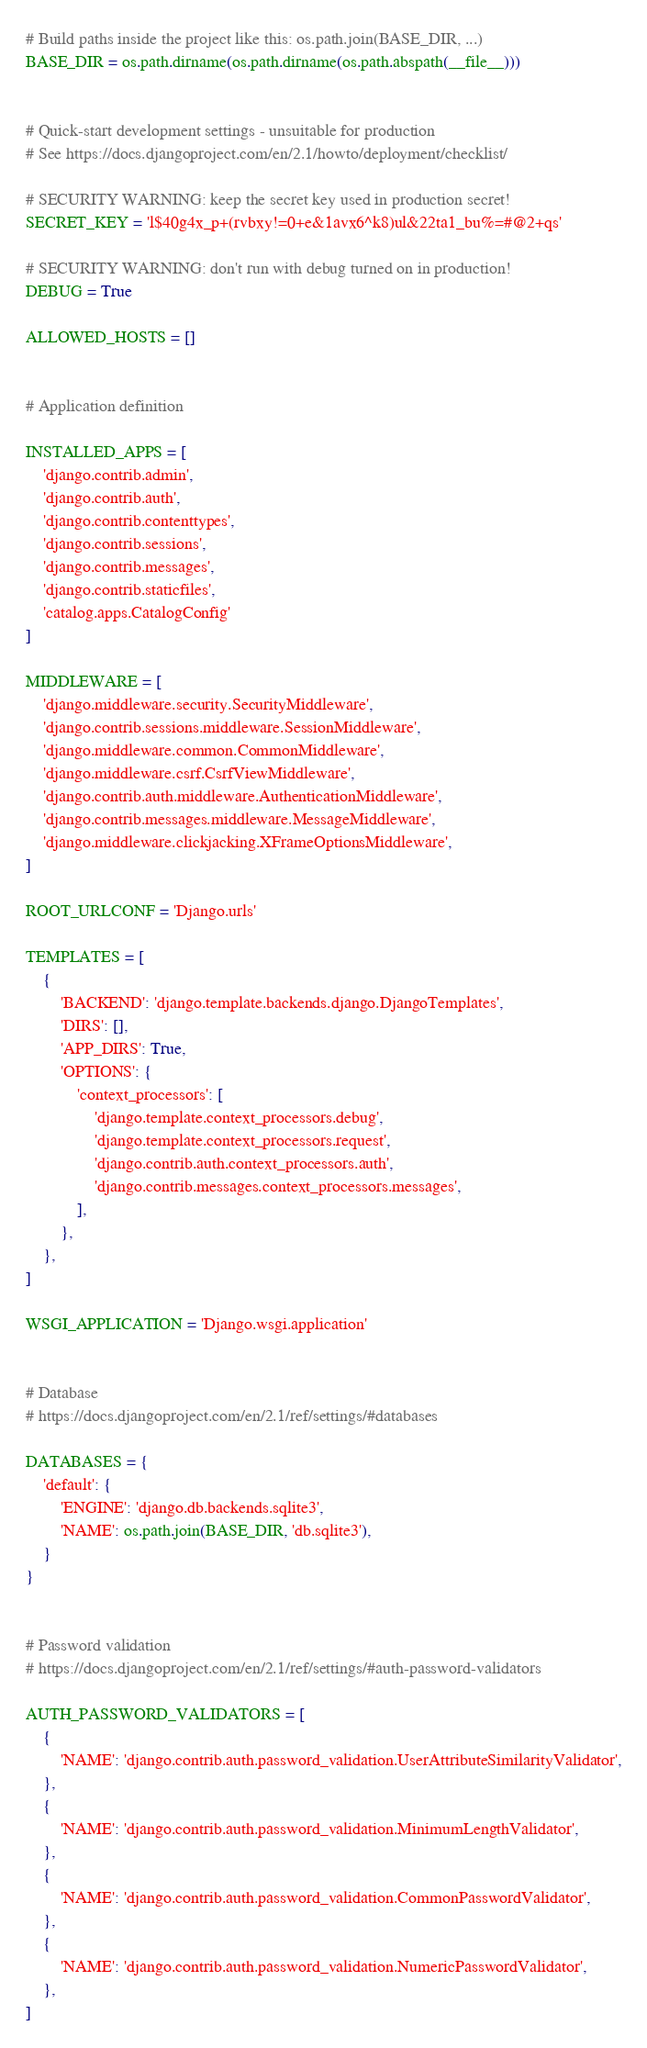<code> <loc_0><loc_0><loc_500><loc_500><_Python_># Build paths inside the project like this: os.path.join(BASE_DIR, ...)
BASE_DIR = os.path.dirname(os.path.dirname(os.path.abspath(__file__)))


# Quick-start development settings - unsuitable for production
# See https://docs.djangoproject.com/en/2.1/howto/deployment/checklist/

# SECURITY WARNING: keep the secret key used in production secret!
SECRET_KEY = 'l$40g4x_p+(rvbxy!=0+e&1avx6^k8)ul&22ta1_bu%=#@2+qs'

# SECURITY WARNING: don't run with debug turned on in production!
DEBUG = True

ALLOWED_HOSTS = []


# Application definition

INSTALLED_APPS = [
    'django.contrib.admin',
    'django.contrib.auth',
    'django.contrib.contenttypes',
    'django.contrib.sessions',
    'django.contrib.messages',
    'django.contrib.staticfiles',
    'catalog.apps.CatalogConfig'
]

MIDDLEWARE = [
    'django.middleware.security.SecurityMiddleware',
    'django.contrib.sessions.middleware.SessionMiddleware',
    'django.middleware.common.CommonMiddleware',
    'django.middleware.csrf.CsrfViewMiddleware',
    'django.contrib.auth.middleware.AuthenticationMiddleware',
    'django.contrib.messages.middleware.MessageMiddleware',
    'django.middleware.clickjacking.XFrameOptionsMiddleware',
]

ROOT_URLCONF = 'Django.urls'

TEMPLATES = [
    {
        'BACKEND': 'django.template.backends.django.DjangoTemplates',
        'DIRS': [],
        'APP_DIRS': True,
        'OPTIONS': {
            'context_processors': [
                'django.template.context_processors.debug',
                'django.template.context_processors.request',
                'django.contrib.auth.context_processors.auth',
                'django.contrib.messages.context_processors.messages',
            ],
        },
    },
]

WSGI_APPLICATION = 'Django.wsgi.application'


# Database
# https://docs.djangoproject.com/en/2.1/ref/settings/#databases

DATABASES = {
    'default': {
        'ENGINE': 'django.db.backends.sqlite3',
        'NAME': os.path.join(BASE_DIR, 'db.sqlite3'),
    }
}


# Password validation
# https://docs.djangoproject.com/en/2.1/ref/settings/#auth-password-validators

AUTH_PASSWORD_VALIDATORS = [
    {
        'NAME': 'django.contrib.auth.password_validation.UserAttributeSimilarityValidator',
    },
    {
        'NAME': 'django.contrib.auth.password_validation.MinimumLengthValidator',
    },
    {
        'NAME': 'django.contrib.auth.password_validation.CommonPasswordValidator',
    },
    {
        'NAME': 'django.contrib.auth.password_validation.NumericPasswordValidator',
    },
]

</code> 